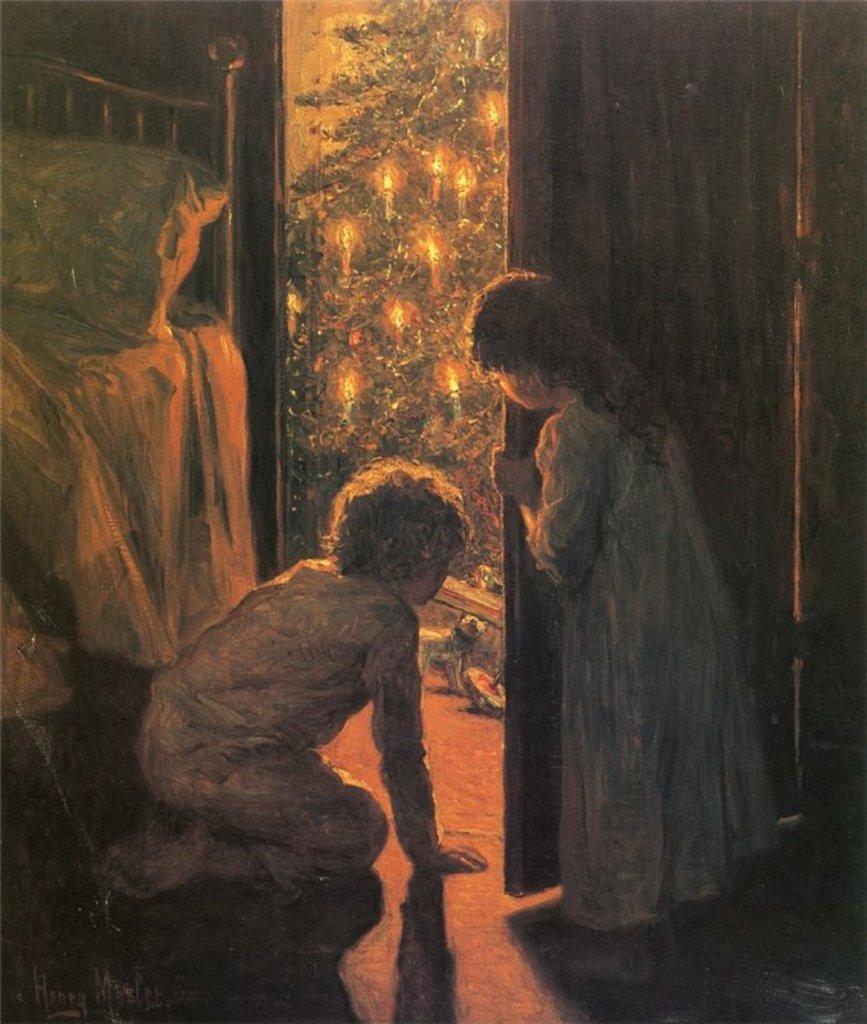Could you give a brief overview of what you see in this image? In this image we can see a drawing of a boy sitting on his knees and a girl standing beside him holding the door. We can also see a bed beside them with a pillow and a tree with some candles. 